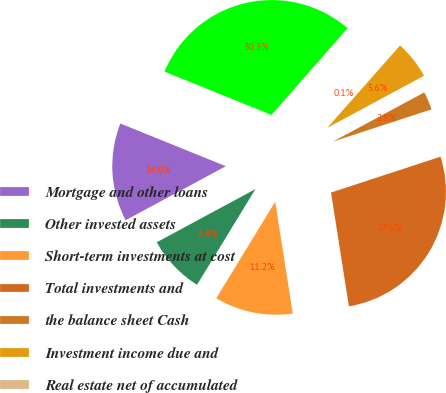Convert chart to OTSL. <chart><loc_0><loc_0><loc_500><loc_500><pie_chart><fcel>Mortgage and other loans<fcel>Other invested assets<fcel>Short-term investments at cost<fcel>Total investments and<fcel>the balance sheet Cash<fcel>Investment income due and<fcel>Real estate net of accumulated<fcel>Total invested assets (a)(b)<nl><fcel>13.99%<fcel>8.41%<fcel>11.2%<fcel>27.55%<fcel>2.83%<fcel>5.62%<fcel>0.05%<fcel>30.34%<nl></chart> 